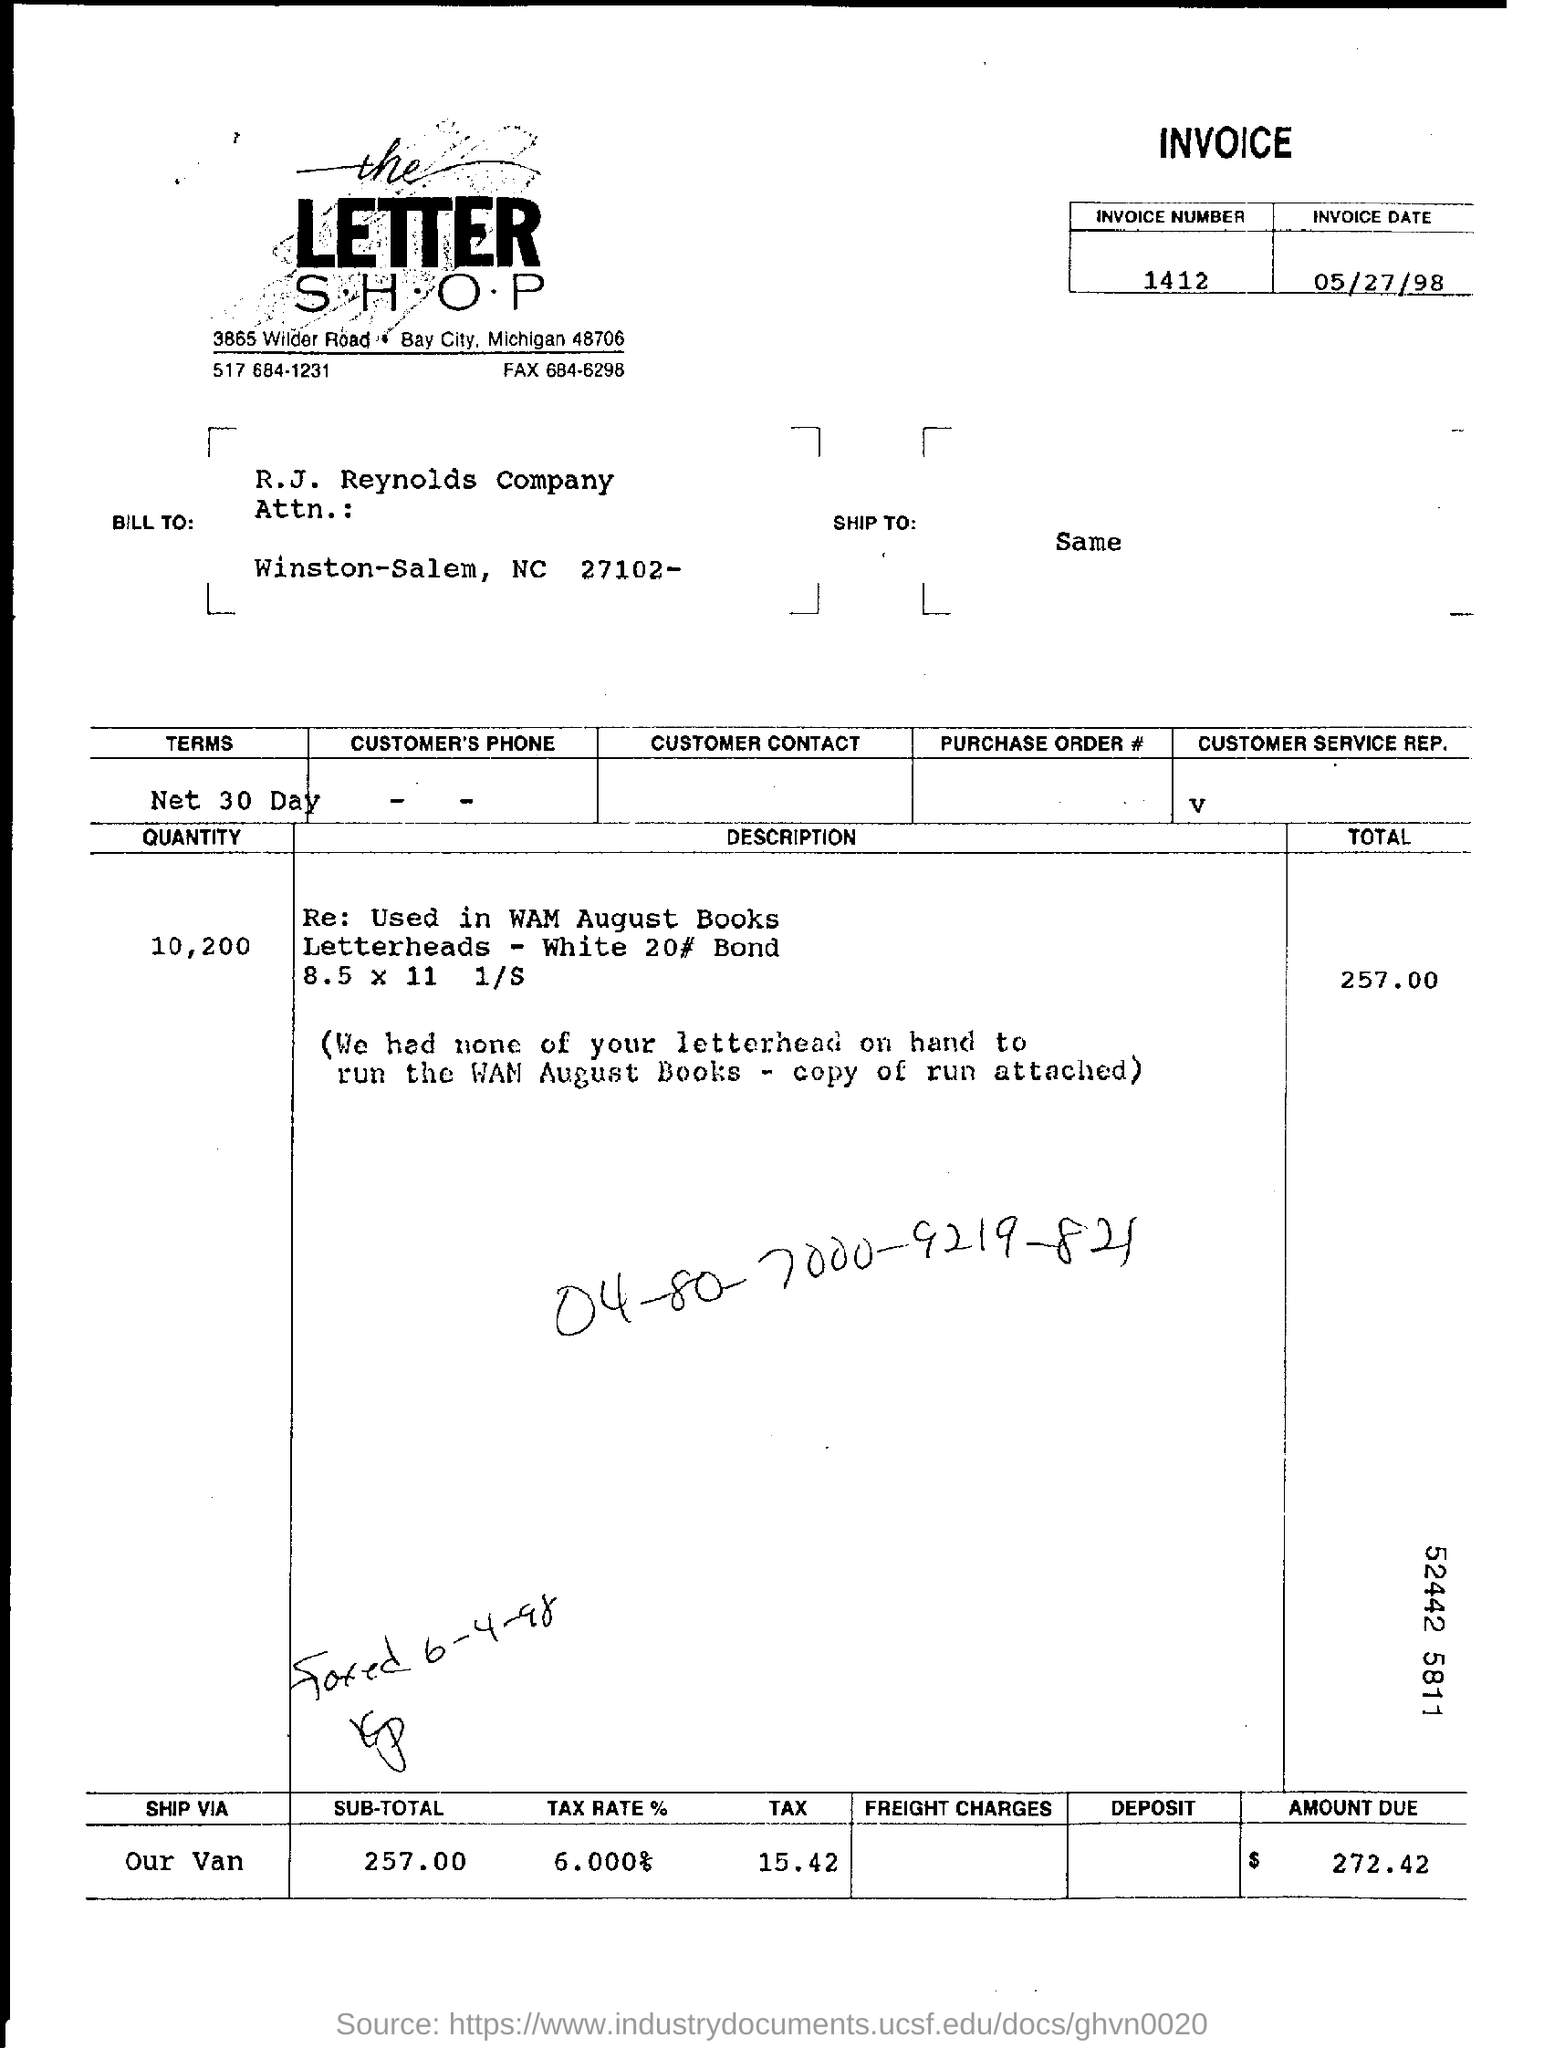What is the invoice number?
Make the answer very short. 1412. What is the invoice date?
Your response must be concise. 05/27/98. What is the tax rate % ?
Your answer should be very brief. 6.000%. What is the amount due?
Ensure brevity in your answer.  $ 272.42. 